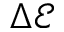<formula> <loc_0><loc_0><loc_500><loc_500>\Delta \mathcal { E }</formula> 